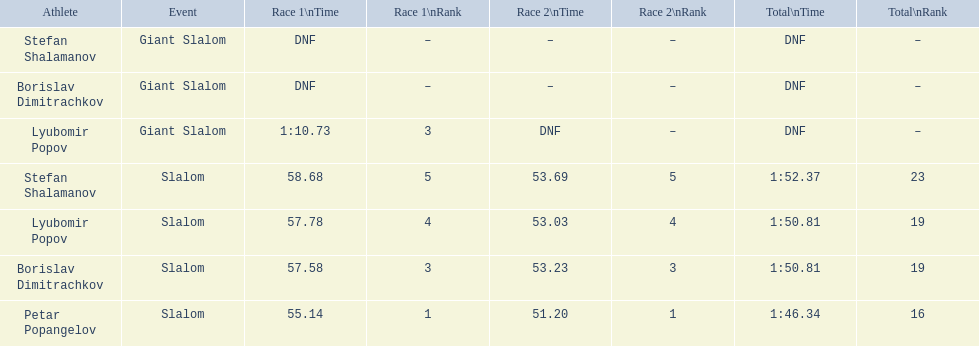Which event is the giant slalom? Giant Slalom, Giant Slalom, Giant Slalom. Which one is lyubomir popov? Lyubomir Popov. What is race 1 tim? 1:10.73. 